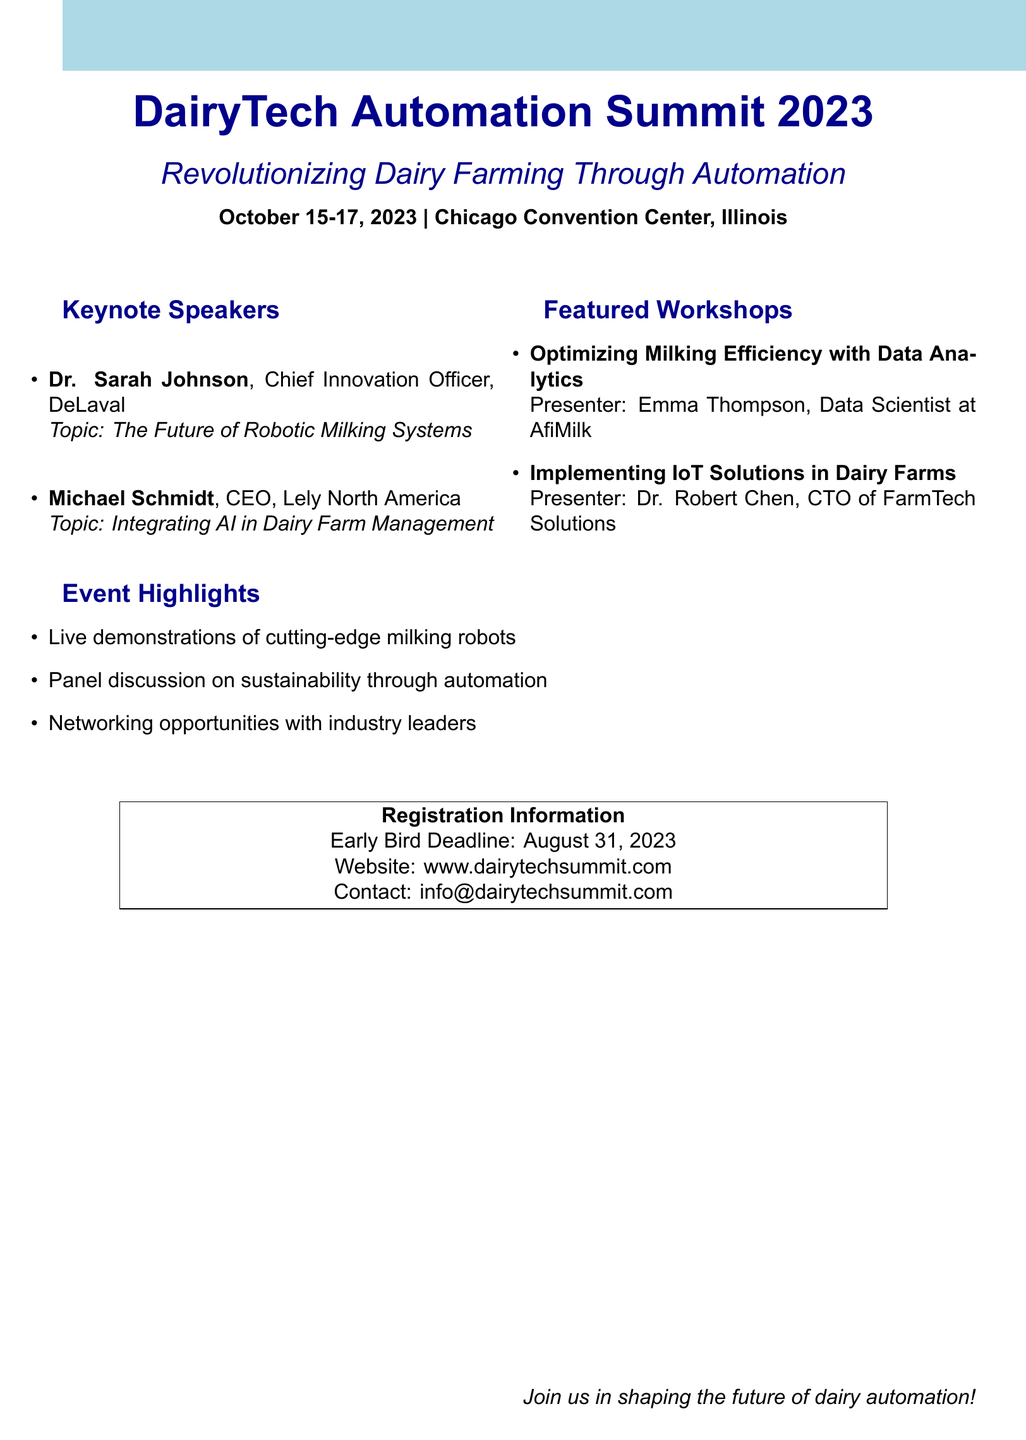What are the dates of the conference? The conference will take place from October 15-17, 2023, as stated in the document.
Answer: October 15-17, 2023 Who is the presenter for the workshop on optimizing milking efficiency? The document lists Emma Thompson as the presenter for this workshop.
Answer: Emma Thompson What is the theme of the DairyTech Automation Summit 2023? The theme is specified in the document as "Revolutionizing Dairy Farming Through Automation."
Answer: Revolutionizing Dairy Farming Through Automation When is the early bird registration deadline? According to the registration information, the early bird deadline is August 31, 2023.
Answer: August 31, 2023 What type of event is this document promoting? The document promotes a conference, as indicated by the content and structure throughout.
Answer: Conference Who are the keynote speakers at the summit? The document lists Dr. Sarah Johnson and Michael Schmidt as the keynote speakers.
Answer: Dr. Sarah Johnson, Michael Schmidt What are the highlights of the event? The highlights include live demonstrations, a panel discussion, and networking opportunities, which are listed in the document.
Answer: Live demonstrations, panel discussion, networking opportunities Where is the conference located? The document specifies that the location of the conference is the Chicago Convention Center, Illinois.
Answer: Chicago Convention Center, Illinois What company does Dr. Robert Chen represent? The document states that Dr. Robert Chen is the CTO of FarmTech Solutions, which indicates the company he represents.
Answer: FarmTech Solutions 